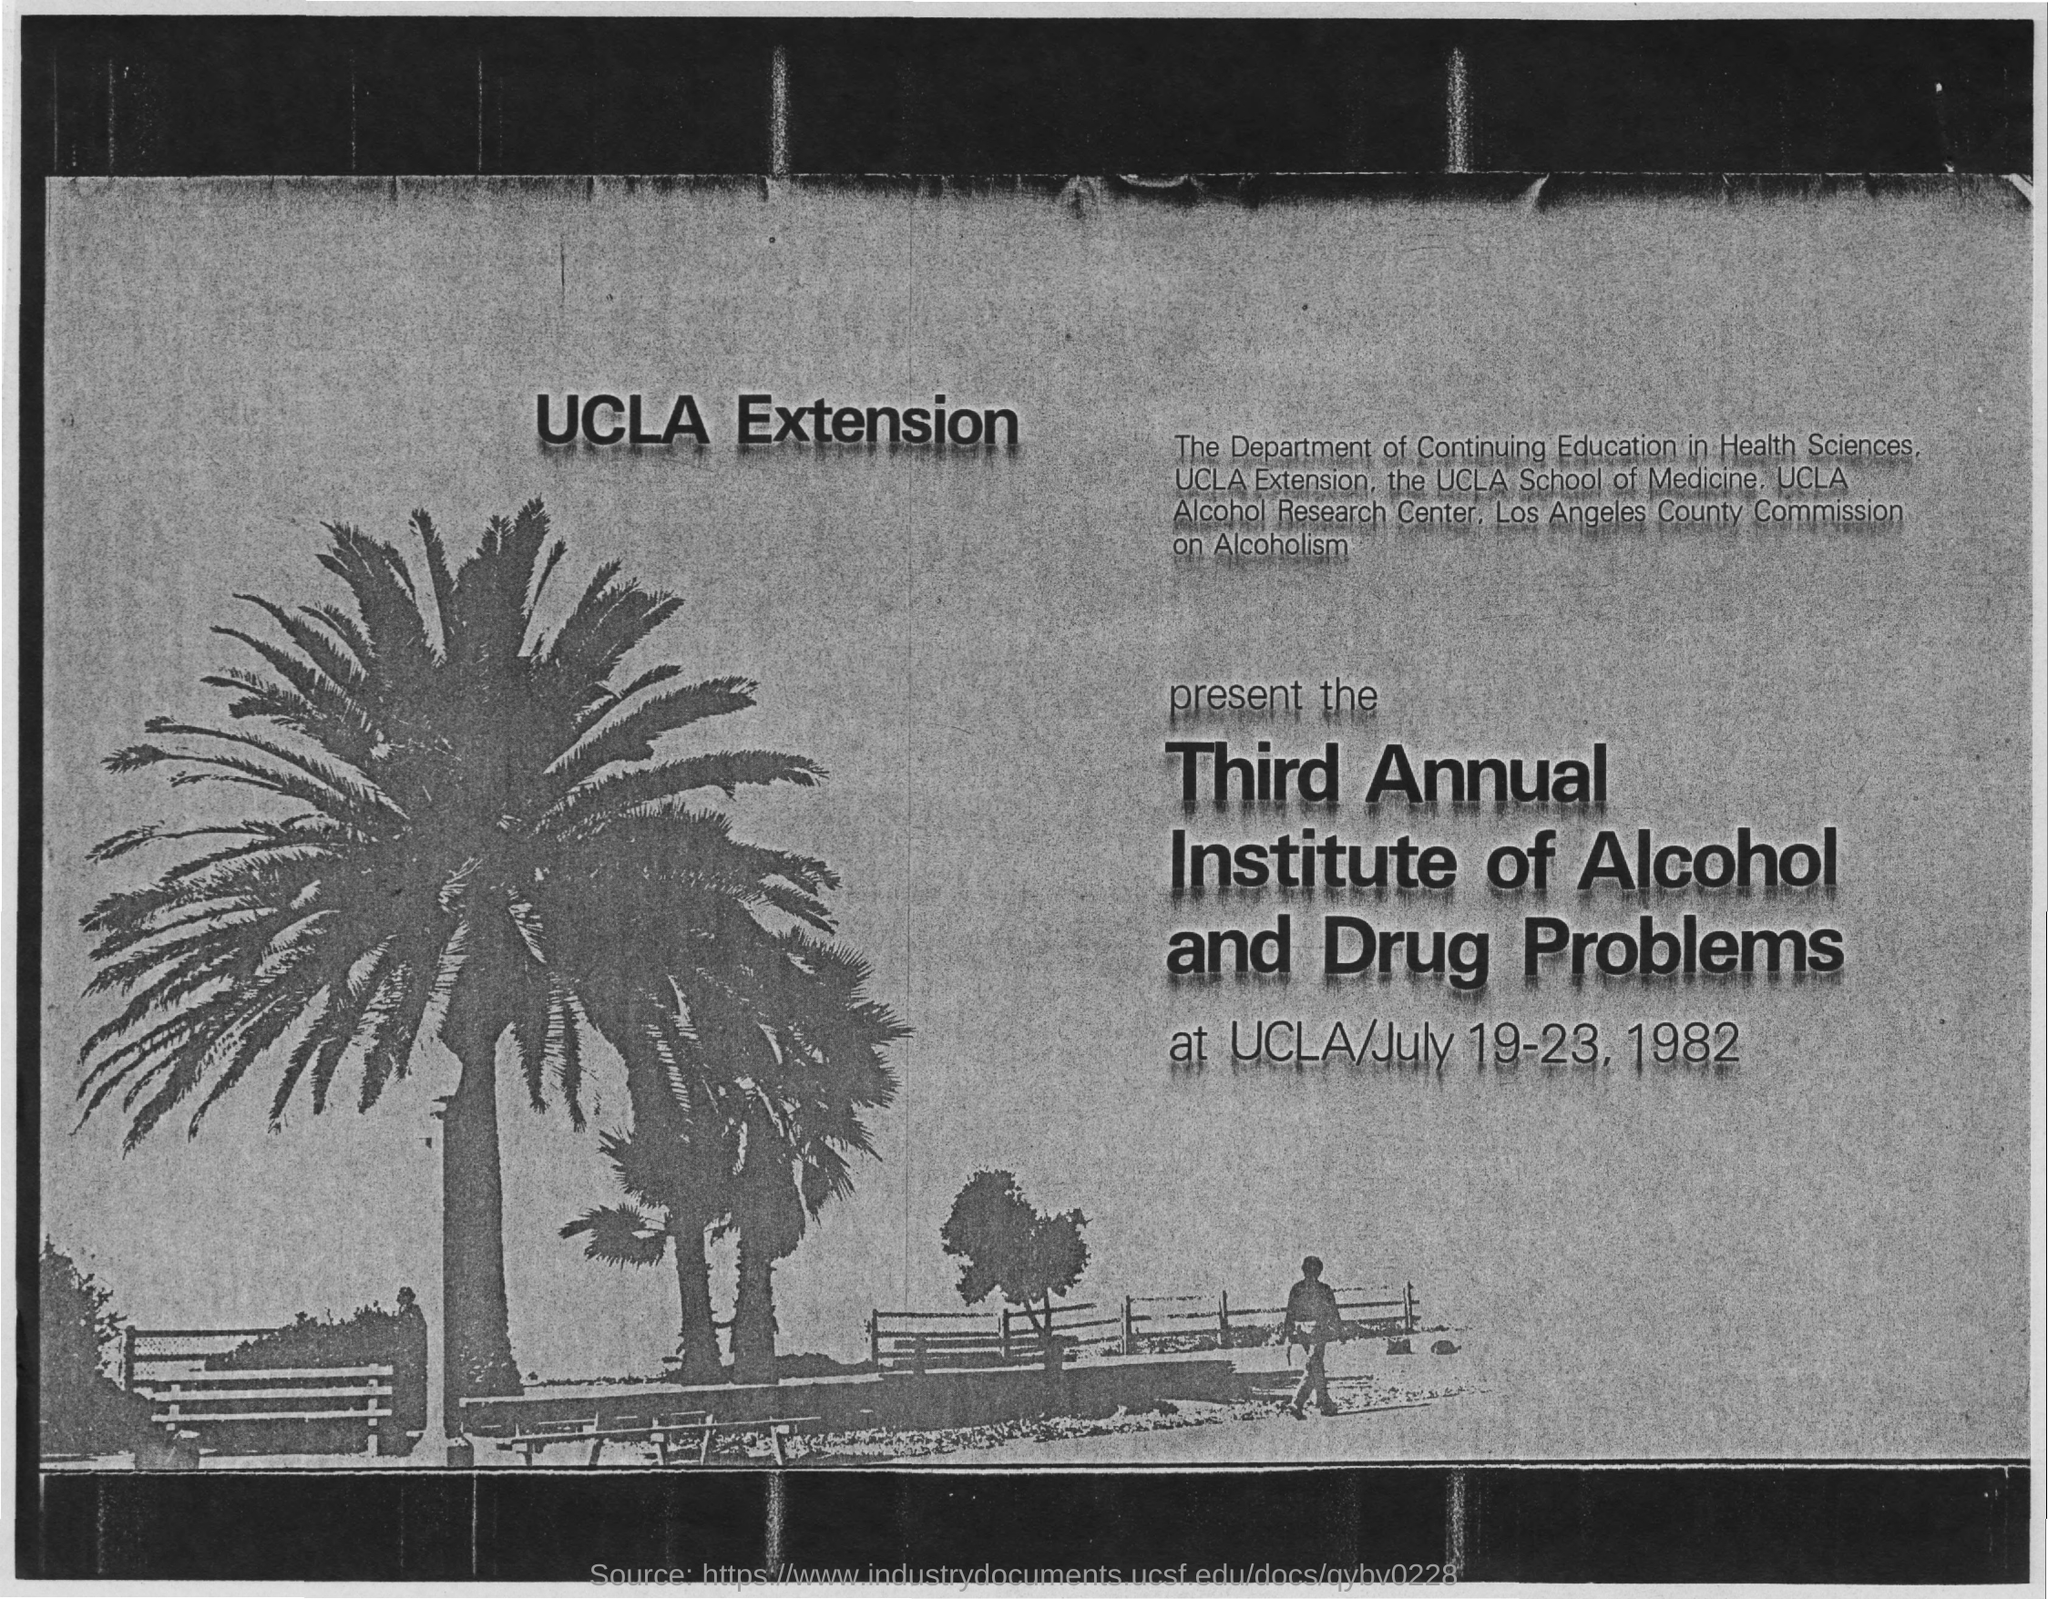Give some essential details in this illustration. The program is located at UCLA. The program will take place from July 19-23, 1982. 